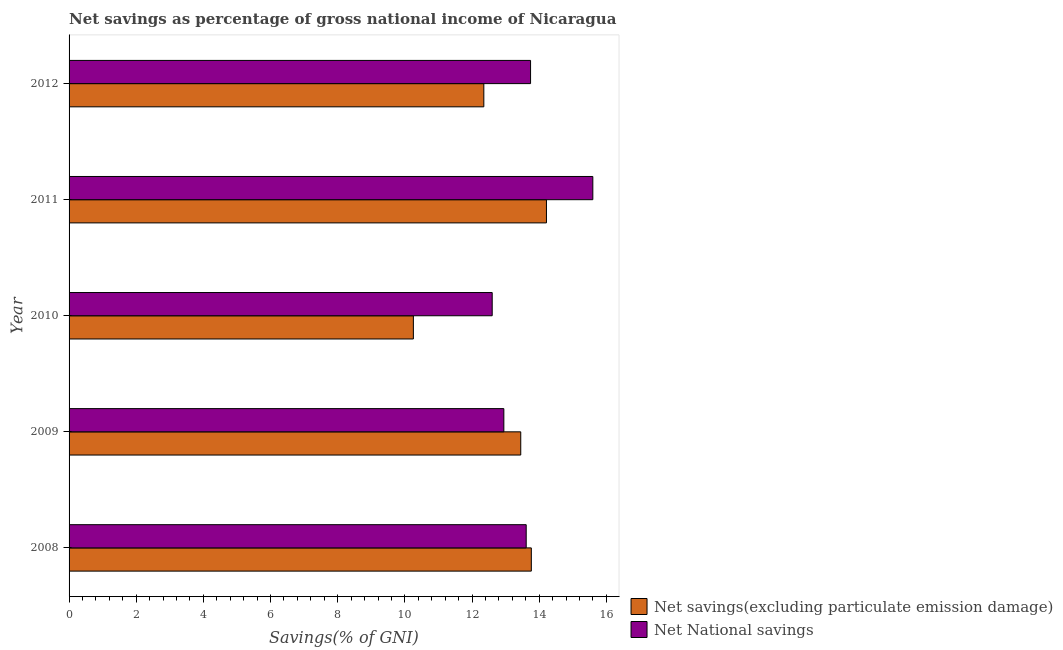How many different coloured bars are there?
Your answer should be very brief. 2. Are the number of bars per tick equal to the number of legend labels?
Your answer should be very brief. Yes. How many bars are there on the 2nd tick from the top?
Your response must be concise. 2. What is the label of the 3rd group of bars from the top?
Keep it short and to the point. 2010. In how many cases, is the number of bars for a given year not equal to the number of legend labels?
Provide a short and direct response. 0. What is the net national savings in 2010?
Your answer should be compact. 12.6. Across all years, what is the maximum net savings(excluding particulate emission damage)?
Your answer should be compact. 14.22. Across all years, what is the minimum net national savings?
Provide a short and direct response. 12.6. In which year was the net national savings maximum?
Provide a succinct answer. 2011. What is the total net savings(excluding particulate emission damage) in the graph?
Your response must be concise. 64.04. What is the difference between the net savings(excluding particulate emission damage) in 2008 and that in 2011?
Keep it short and to the point. -0.45. What is the difference between the net savings(excluding particulate emission damage) in 2010 and the net national savings in 2012?
Keep it short and to the point. -3.49. In the year 2009, what is the difference between the net national savings and net savings(excluding particulate emission damage)?
Your answer should be very brief. -0.5. What is the ratio of the net savings(excluding particulate emission damage) in 2009 to that in 2011?
Make the answer very short. 0.95. Is the net savings(excluding particulate emission damage) in 2008 less than that in 2011?
Offer a very short reply. Yes. What is the difference between the highest and the second highest net savings(excluding particulate emission damage)?
Offer a very short reply. 0.45. What is the difference between the highest and the lowest net national savings?
Your answer should be very brief. 3. What does the 2nd bar from the top in 2009 represents?
Provide a short and direct response. Net savings(excluding particulate emission damage). What does the 1st bar from the bottom in 2009 represents?
Your answer should be compact. Net savings(excluding particulate emission damage). Are all the bars in the graph horizontal?
Give a very brief answer. Yes. What is the difference between two consecutive major ticks on the X-axis?
Provide a short and direct response. 2. Does the graph contain any zero values?
Offer a terse response. No. Does the graph contain grids?
Keep it short and to the point. No. What is the title of the graph?
Make the answer very short. Net savings as percentage of gross national income of Nicaragua. What is the label or title of the X-axis?
Keep it short and to the point. Savings(% of GNI). What is the label or title of the Y-axis?
Give a very brief answer. Year. What is the Savings(% of GNI) of Net savings(excluding particulate emission damage) in 2008?
Ensure brevity in your answer.  13.77. What is the Savings(% of GNI) of Net National savings in 2008?
Your response must be concise. 13.61. What is the Savings(% of GNI) of Net savings(excluding particulate emission damage) in 2009?
Make the answer very short. 13.45. What is the Savings(% of GNI) in Net National savings in 2009?
Your answer should be compact. 12.95. What is the Savings(% of GNI) of Net savings(excluding particulate emission damage) in 2010?
Your answer should be very brief. 10.25. What is the Savings(% of GNI) in Net National savings in 2010?
Offer a terse response. 12.6. What is the Savings(% of GNI) of Net savings(excluding particulate emission damage) in 2011?
Offer a very short reply. 14.22. What is the Savings(% of GNI) in Net National savings in 2011?
Provide a short and direct response. 15.6. What is the Savings(% of GNI) of Net savings(excluding particulate emission damage) in 2012?
Offer a terse response. 12.35. What is the Savings(% of GNI) in Net National savings in 2012?
Offer a very short reply. 13.74. Across all years, what is the maximum Savings(% of GNI) in Net savings(excluding particulate emission damage)?
Offer a very short reply. 14.22. Across all years, what is the maximum Savings(% of GNI) of Net National savings?
Your answer should be compact. 15.6. Across all years, what is the minimum Savings(% of GNI) of Net savings(excluding particulate emission damage)?
Your response must be concise. 10.25. Across all years, what is the minimum Savings(% of GNI) of Net National savings?
Keep it short and to the point. 12.6. What is the total Savings(% of GNI) of Net savings(excluding particulate emission damage) in the graph?
Ensure brevity in your answer.  64.04. What is the total Savings(% of GNI) in Net National savings in the graph?
Your answer should be very brief. 68.5. What is the difference between the Savings(% of GNI) in Net savings(excluding particulate emission damage) in 2008 and that in 2009?
Provide a short and direct response. 0.31. What is the difference between the Savings(% of GNI) of Net National savings in 2008 and that in 2009?
Give a very brief answer. 0.67. What is the difference between the Savings(% of GNI) of Net savings(excluding particulate emission damage) in 2008 and that in 2010?
Your answer should be compact. 3.51. What is the difference between the Savings(% of GNI) in Net National savings in 2008 and that in 2010?
Keep it short and to the point. 1.01. What is the difference between the Savings(% of GNI) in Net savings(excluding particulate emission damage) in 2008 and that in 2011?
Offer a terse response. -0.45. What is the difference between the Savings(% of GNI) of Net National savings in 2008 and that in 2011?
Provide a short and direct response. -1.98. What is the difference between the Savings(% of GNI) in Net savings(excluding particulate emission damage) in 2008 and that in 2012?
Your response must be concise. 1.41. What is the difference between the Savings(% of GNI) of Net National savings in 2008 and that in 2012?
Provide a succinct answer. -0.13. What is the difference between the Savings(% of GNI) of Net savings(excluding particulate emission damage) in 2009 and that in 2010?
Make the answer very short. 3.2. What is the difference between the Savings(% of GNI) of Net National savings in 2009 and that in 2010?
Provide a short and direct response. 0.35. What is the difference between the Savings(% of GNI) in Net savings(excluding particulate emission damage) in 2009 and that in 2011?
Keep it short and to the point. -0.77. What is the difference between the Savings(% of GNI) of Net National savings in 2009 and that in 2011?
Your answer should be very brief. -2.65. What is the difference between the Savings(% of GNI) of Net savings(excluding particulate emission damage) in 2009 and that in 2012?
Make the answer very short. 1.1. What is the difference between the Savings(% of GNI) in Net National savings in 2009 and that in 2012?
Provide a succinct answer. -0.8. What is the difference between the Savings(% of GNI) in Net savings(excluding particulate emission damage) in 2010 and that in 2011?
Keep it short and to the point. -3.96. What is the difference between the Savings(% of GNI) of Net National savings in 2010 and that in 2011?
Give a very brief answer. -3. What is the difference between the Savings(% of GNI) of Net savings(excluding particulate emission damage) in 2010 and that in 2012?
Your answer should be compact. -2.1. What is the difference between the Savings(% of GNI) in Net National savings in 2010 and that in 2012?
Offer a terse response. -1.14. What is the difference between the Savings(% of GNI) in Net savings(excluding particulate emission damage) in 2011 and that in 2012?
Make the answer very short. 1.86. What is the difference between the Savings(% of GNI) in Net National savings in 2011 and that in 2012?
Make the answer very short. 1.85. What is the difference between the Savings(% of GNI) in Net savings(excluding particulate emission damage) in 2008 and the Savings(% of GNI) in Net National savings in 2009?
Offer a terse response. 0.82. What is the difference between the Savings(% of GNI) in Net savings(excluding particulate emission damage) in 2008 and the Savings(% of GNI) in Net National savings in 2010?
Your answer should be compact. 1.17. What is the difference between the Savings(% of GNI) in Net savings(excluding particulate emission damage) in 2008 and the Savings(% of GNI) in Net National savings in 2011?
Your answer should be compact. -1.83. What is the difference between the Savings(% of GNI) in Net savings(excluding particulate emission damage) in 2008 and the Savings(% of GNI) in Net National savings in 2012?
Keep it short and to the point. 0.02. What is the difference between the Savings(% of GNI) of Net savings(excluding particulate emission damage) in 2009 and the Savings(% of GNI) of Net National savings in 2010?
Keep it short and to the point. 0.85. What is the difference between the Savings(% of GNI) of Net savings(excluding particulate emission damage) in 2009 and the Savings(% of GNI) of Net National savings in 2011?
Offer a very short reply. -2.15. What is the difference between the Savings(% of GNI) of Net savings(excluding particulate emission damage) in 2009 and the Savings(% of GNI) of Net National savings in 2012?
Offer a terse response. -0.29. What is the difference between the Savings(% of GNI) of Net savings(excluding particulate emission damage) in 2010 and the Savings(% of GNI) of Net National savings in 2011?
Your answer should be compact. -5.34. What is the difference between the Savings(% of GNI) of Net savings(excluding particulate emission damage) in 2010 and the Savings(% of GNI) of Net National savings in 2012?
Make the answer very short. -3.49. What is the difference between the Savings(% of GNI) in Net savings(excluding particulate emission damage) in 2011 and the Savings(% of GNI) in Net National savings in 2012?
Your answer should be very brief. 0.47. What is the average Savings(% of GNI) in Net savings(excluding particulate emission damage) per year?
Offer a very short reply. 12.81. What is the average Savings(% of GNI) of Net National savings per year?
Make the answer very short. 13.7. In the year 2008, what is the difference between the Savings(% of GNI) in Net savings(excluding particulate emission damage) and Savings(% of GNI) in Net National savings?
Your answer should be compact. 0.15. In the year 2009, what is the difference between the Savings(% of GNI) of Net savings(excluding particulate emission damage) and Savings(% of GNI) of Net National savings?
Your answer should be compact. 0.5. In the year 2010, what is the difference between the Savings(% of GNI) of Net savings(excluding particulate emission damage) and Savings(% of GNI) of Net National savings?
Keep it short and to the point. -2.35. In the year 2011, what is the difference between the Savings(% of GNI) in Net savings(excluding particulate emission damage) and Savings(% of GNI) in Net National savings?
Offer a very short reply. -1.38. In the year 2012, what is the difference between the Savings(% of GNI) in Net savings(excluding particulate emission damage) and Savings(% of GNI) in Net National savings?
Ensure brevity in your answer.  -1.39. What is the ratio of the Savings(% of GNI) of Net savings(excluding particulate emission damage) in 2008 to that in 2009?
Provide a succinct answer. 1.02. What is the ratio of the Savings(% of GNI) in Net National savings in 2008 to that in 2009?
Your response must be concise. 1.05. What is the ratio of the Savings(% of GNI) in Net savings(excluding particulate emission damage) in 2008 to that in 2010?
Your response must be concise. 1.34. What is the ratio of the Savings(% of GNI) of Net National savings in 2008 to that in 2010?
Your answer should be compact. 1.08. What is the ratio of the Savings(% of GNI) of Net savings(excluding particulate emission damage) in 2008 to that in 2011?
Give a very brief answer. 0.97. What is the ratio of the Savings(% of GNI) in Net National savings in 2008 to that in 2011?
Make the answer very short. 0.87. What is the ratio of the Savings(% of GNI) of Net savings(excluding particulate emission damage) in 2008 to that in 2012?
Ensure brevity in your answer.  1.11. What is the ratio of the Savings(% of GNI) of Net National savings in 2008 to that in 2012?
Your response must be concise. 0.99. What is the ratio of the Savings(% of GNI) in Net savings(excluding particulate emission damage) in 2009 to that in 2010?
Provide a succinct answer. 1.31. What is the ratio of the Savings(% of GNI) in Net National savings in 2009 to that in 2010?
Offer a very short reply. 1.03. What is the ratio of the Savings(% of GNI) of Net savings(excluding particulate emission damage) in 2009 to that in 2011?
Give a very brief answer. 0.95. What is the ratio of the Savings(% of GNI) of Net National savings in 2009 to that in 2011?
Ensure brevity in your answer.  0.83. What is the ratio of the Savings(% of GNI) in Net savings(excluding particulate emission damage) in 2009 to that in 2012?
Provide a short and direct response. 1.09. What is the ratio of the Savings(% of GNI) of Net National savings in 2009 to that in 2012?
Offer a very short reply. 0.94. What is the ratio of the Savings(% of GNI) of Net savings(excluding particulate emission damage) in 2010 to that in 2011?
Offer a very short reply. 0.72. What is the ratio of the Savings(% of GNI) in Net National savings in 2010 to that in 2011?
Offer a terse response. 0.81. What is the ratio of the Savings(% of GNI) in Net savings(excluding particulate emission damage) in 2010 to that in 2012?
Your response must be concise. 0.83. What is the ratio of the Savings(% of GNI) in Net National savings in 2010 to that in 2012?
Your response must be concise. 0.92. What is the ratio of the Savings(% of GNI) in Net savings(excluding particulate emission damage) in 2011 to that in 2012?
Give a very brief answer. 1.15. What is the ratio of the Savings(% of GNI) of Net National savings in 2011 to that in 2012?
Make the answer very short. 1.13. What is the difference between the highest and the second highest Savings(% of GNI) of Net savings(excluding particulate emission damage)?
Your response must be concise. 0.45. What is the difference between the highest and the second highest Savings(% of GNI) in Net National savings?
Your answer should be compact. 1.85. What is the difference between the highest and the lowest Savings(% of GNI) in Net savings(excluding particulate emission damage)?
Provide a short and direct response. 3.96. What is the difference between the highest and the lowest Savings(% of GNI) in Net National savings?
Make the answer very short. 3. 